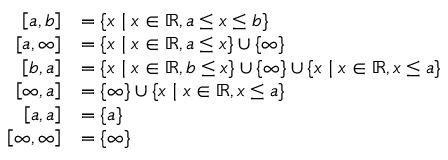<formula> <loc_0><loc_0><loc_500><loc_500>{ \begin{array} { r l } { \left [ a , b \right ] } & { = \{ x | x \in \mathbb { R } , a \leq x \leq b \} } \\ { \left [ a , \infty \right ] } & { = \{ x | x \in \mathbb { R } , a \leq x \} \cup \{ \infty \} } \\ { \left [ b , a \right ] } & { = \{ x | x \in \mathbb { R } , b \leq x \} \cup \{ \infty \} \cup \{ x | x \in \mathbb { R } , x \leq a \} } \\ { \left [ \infty , a \right ] } & { = \{ \infty \} \cup \{ x | x \in \mathbb { R } , x \leq a \} } \\ { \left [ a , a \right ] } & { = \{ a \} } \\ { \left [ \infty , \infty \right ] } & { = \{ \infty \} } \end{array} }</formula> 